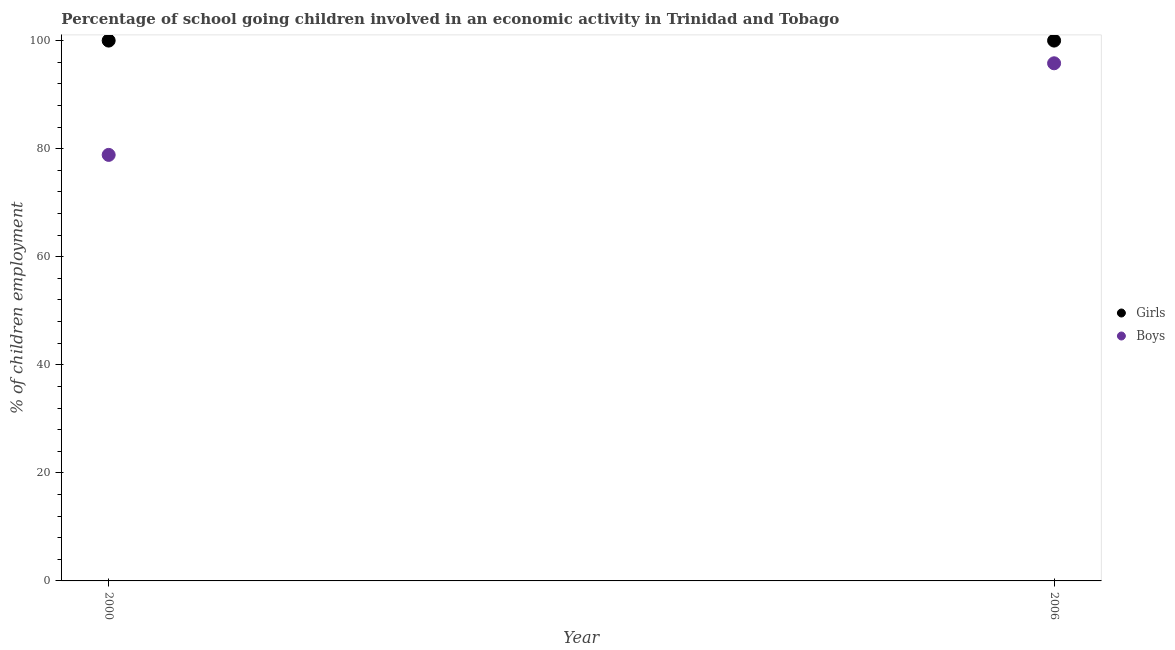What is the percentage of school going girls in 2006?
Offer a terse response. 100. Across all years, what is the maximum percentage of school going girls?
Offer a very short reply. 100. Across all years, what is the minimum percentage of school going girls?
Give a very brief answer. 100. In which year was the percentage of school going boys maximum?
Make the answer very short. 2006. What is the total percentage of school going girls in the graph?
Your response must be concise. 200. What is the difference between the percentage of school going boys in 2000 and that in 2006?
Your answer should be compact. -16.95. What is the difference between the percentage of school going boys in 2006 and the percentage of school going girls in 2000?
Ensure brevity in your answer.  -4.2. In the year 2000, what is the difference between the percentage of school going girls and percentage of school going boys?
Your response must be concise. 21.15. In how many years, is the percentage of school going girls greater than 76 %?
Give a very brief answer. 2. What is the ratio of the percentage of school going girls in 2000 to that in 2006?
Offer a terse response. 1. Is the percentage of school going boys in 2000 less than that in 2006?
Provide a short and direct response. Yes. In how many years, is the percentage of school going boys greater than the average percentage of school going boys taken over all years?
Give a very brief answer. 1. Does the percentage of school going girls monotonically increase over the years?
Ensure brevity in your answer.  No. Is the percentage of school going boys strictly greater than the percentage of school going girls over the years?
Make the answer very short. No. How many years are there in the graph?
Keep it short and to the point. 2. What is the difference between two consecutive major ticks on the Y-axis?
Provide a succinct answer. 20. Does the graph contain grids?
Provide a short and direct response. No. How are the legend labels stacked?
Keep it short and to the point. Vertical. What is the title of the graph?
Offer a very short reply. Percentage of school going children involved in an economic activity in Trinidad and Tobago. What is the label or title of the X-axis?
Offer a terse response. Year. What is the label or title of the Y-axis?
Provide a short and direct response. % of children employment. What is the % of children employment in Boys in 2000?
Offer a very short reply. 78.85. What is the % of children employment of Girls in 2006?
Keep it short and to the point. 100. What is the % of children employment in Boys in 2006?
Keep it short and to the point. 95.8. Across all years, what is the maximum % of children employment of Girls?
Make the answer very short. 100. Across all years, what is the maximum % of children employment of Boys?
Make the answer very short. 95.8. Across all years, what is the minimum % of children employment in Girls?
Offer a very short reply. 100. Across all years, what is the minimum % of children employment in Boys?
Provide a short and direct response. 78.85. What is the total % of children employment in Girls in the graph?
Provide a succinct answer. 200. What is the total % of children employment in Boys in the graph?
Your answer should be very brief. 174.65. What is the difference between the % of children employment of Boys in 2000 and that in 2006?
Keep it short and to the point. -16.95. What is the average % of children employment of Boys per year?
Give a very brief answer. 87.32. In the year 2000, what is the difference between the % of children employment of Girls and % of children employment of Boys?
Ensure brevity in your answer.  21.15. In the year 2006, what is the difference between the % of children employment in Girls and % of children employment in Boys?
Your response must be concise. 4.2. What is the ratio of the % of children employment of Girls in 2000 to that in 2006?
Keep it short and to the point. 1. What is the ratio of the % of children employment of Boys in 2000 to that in 2006?
Your answer should be compact. 0.82. What is the difference between the highest and the second highest % of children employment in Girls?
Provide a short and direct response. 0. What is the difference between the highest and the second highest % of children employment in Boys?
Your answer should be compact. 16.95. What is the difference between the highest and the lowest % of children employment in Boys?
Ensure brevity in your answer.  16.95. 